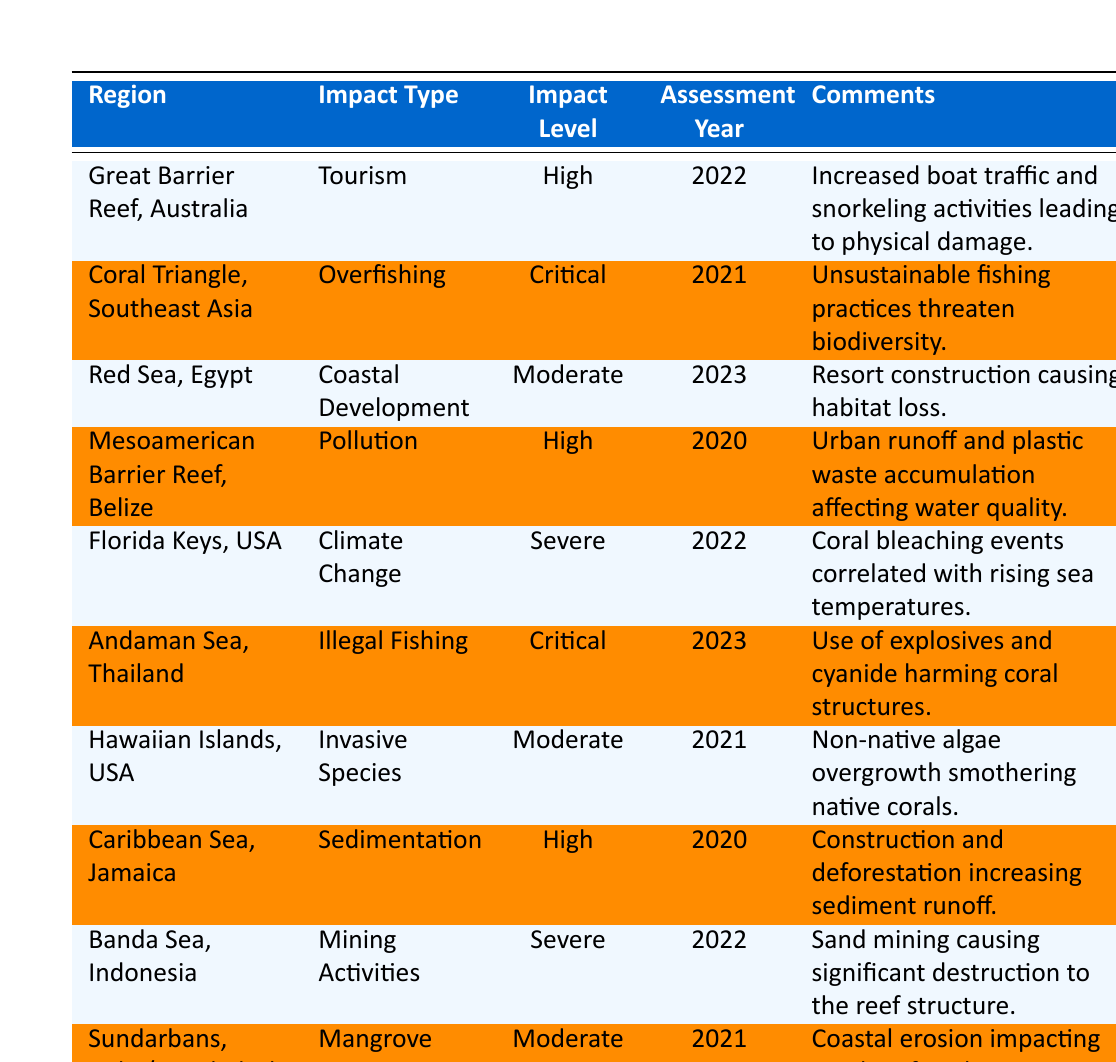What is the impact level assessed for the Coral Triangle, Southeast Asia? The table indicates that the impact level for the Coral Triangle, Southeast Asia is "Critical" as stated in the respective row.
Answer: Critical Which region has the highest impact level regarding overfishing? The Coral Triangle, Southeast Asia is listed with the impact type "Overfishing" and it has a "Critical" impact level, which is the highest recorded for this type of impact.
Answer: Coral Triangle, Southeast Asia What year was the impact in the Red Sea, Egypt assessed? The assessment year for the Red Sea, Egypt is 2023 as mentioned in the corresponding table entry.
Answer: 2023 How many regions have a moderate impact level? By reviewing the table, we can see that there are three regions marked with a "Moderate" impact level: Red Sea, Hawaiian Islands, and Sundarbans.
Answer: 3 Is there any region experiencing severe impacts related to climate change? The Florida Keys, USA shows a "Severe" impact level associated with climate change. Therefore, the answer is yes.
Answer: Yes Which impact type is associated with the Great Barrier Reef, Australia? The impact type for the Great Barrier Reef, Australia is "Tourism" according to the data presented in the table.
Answer: Tourism What can be inferred about the impact of mining activities in the Banda Sea, Indonesia, based on the assessment? The Banda Sea, Indonesia is assessed with a "Severe" impact level related to mining activities, indicating significant damage to the coral structure.
Answer: Severe impact What is the most common impact level across all regions listed? By examining the table, "High" is noted as the most common impact level appearing in four regions: Great Barrier Reef, Mesoamerican Barrier Reef, Caribbean Sea, and Banda Sea.
Answer: High How does the impact of pollution in the Mesoamerican Barrier Reef compare to the impact of coastal development in the Red Sea? The Mesoamerican Barrier Reef has a "High" impact level due to pollution, while the Red Sea has a "Moderate" impact level related to coastal development. Hence, pollution is assessed as more impactful than coastal development in this instance.
Answer: Pollution is more impactful What is the average impact level of the assessed regions? The levels of impact can be categorized into: Severe (2), Critical (2), High (4), Moderate (3). The average can be calculated by assigning numerical values (Severe=4, Critical=3, High=2, Moderate=1), resulting in a weighted average, but clearly counts show that "High" is the most prevalent. Hence, the broad average also trends towards "High".
Answer: High 